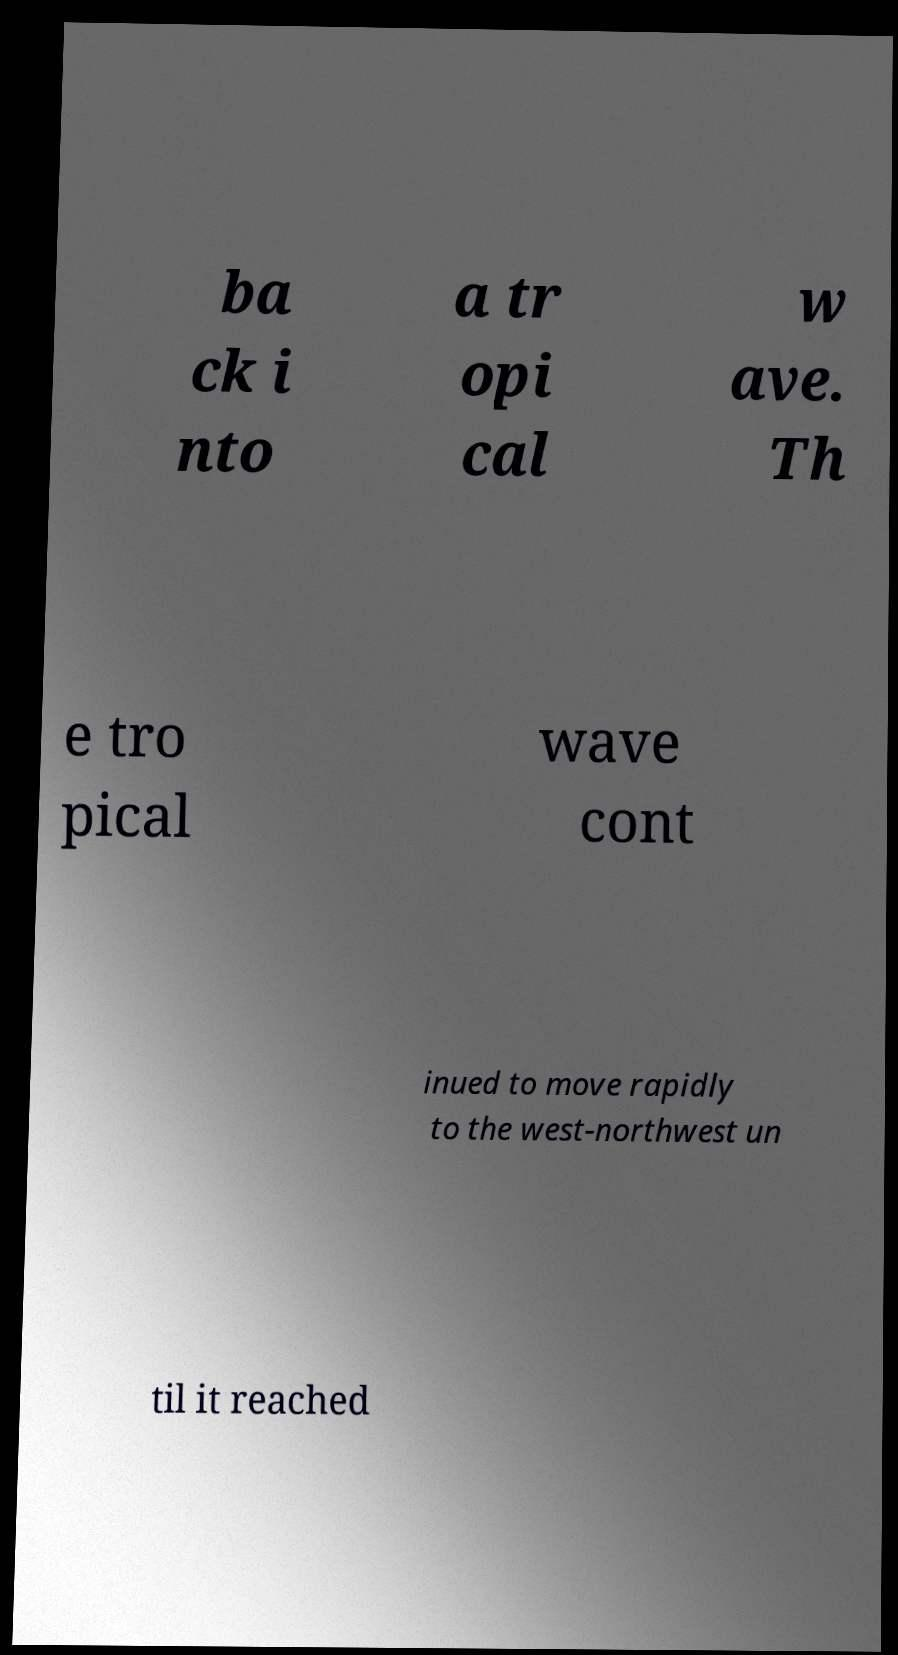Could you extract and type out the text from this image? ba ck i nto a tr opi cal w ave. Th e tro pical wave cont inued to move rapidly to the west-northwest un til it reached 